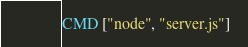<code> <loc_0><loc_0><loc_500><loc_500><_Dockerfile_>CMD ["node", "server.js"]
</code> 